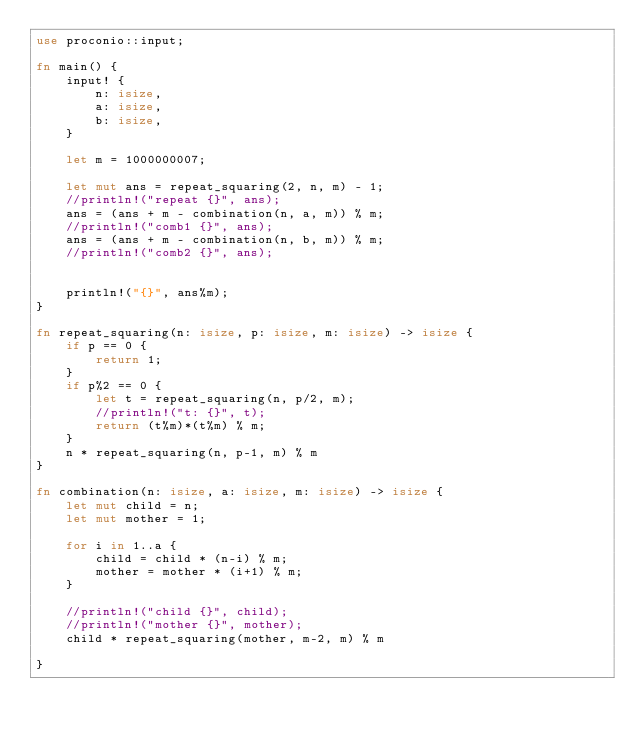<code> <loc_0><loc_0><loc_500><loc_500><_Rust_>use proconio::input;

fn main() {
    input! {
        n: isize,
        a: isize,
        b: isize,
    }

    let m = 1000000007;

    let mut ans = repeat_squaring(2, n, m) - 1;
    //println!("repeat {}", ans);
    ans = (ans + m - combination(n, a, m)) % m;
    //println!("comb1 {}", ans);
    ans = (ans + m - combination(n, b, m)) % m;
    //println!("comb2 {}", ans);


    println!("{}", ans%m);
}

fn repeat_squaring(n: isize, p: isize, m: isize) -> isize {
    if p == 0 {
        return 1;
    }
    if p%2 == 0 {
        let t = repeat_squaring(n, p/2, m);
        //println!("t: {}", t);
        return (t%m)*(t%m) % m;
    }
    n * repeat_squaring(n, p-1, m) % m
}

fn combination(n: isize, a: isize, m: isize) -> isize {
    let mut child = n;
    let mut mother = 1;

    for i in 1..a {
        child = child * (n-i) % m;
        mother = mother * (i+1) % m;
    }

    //println!("child {}", child);
    //println!("mother {}", mother);
    child * repeat_squaring(mother, m-2, m) % m

}</code> 